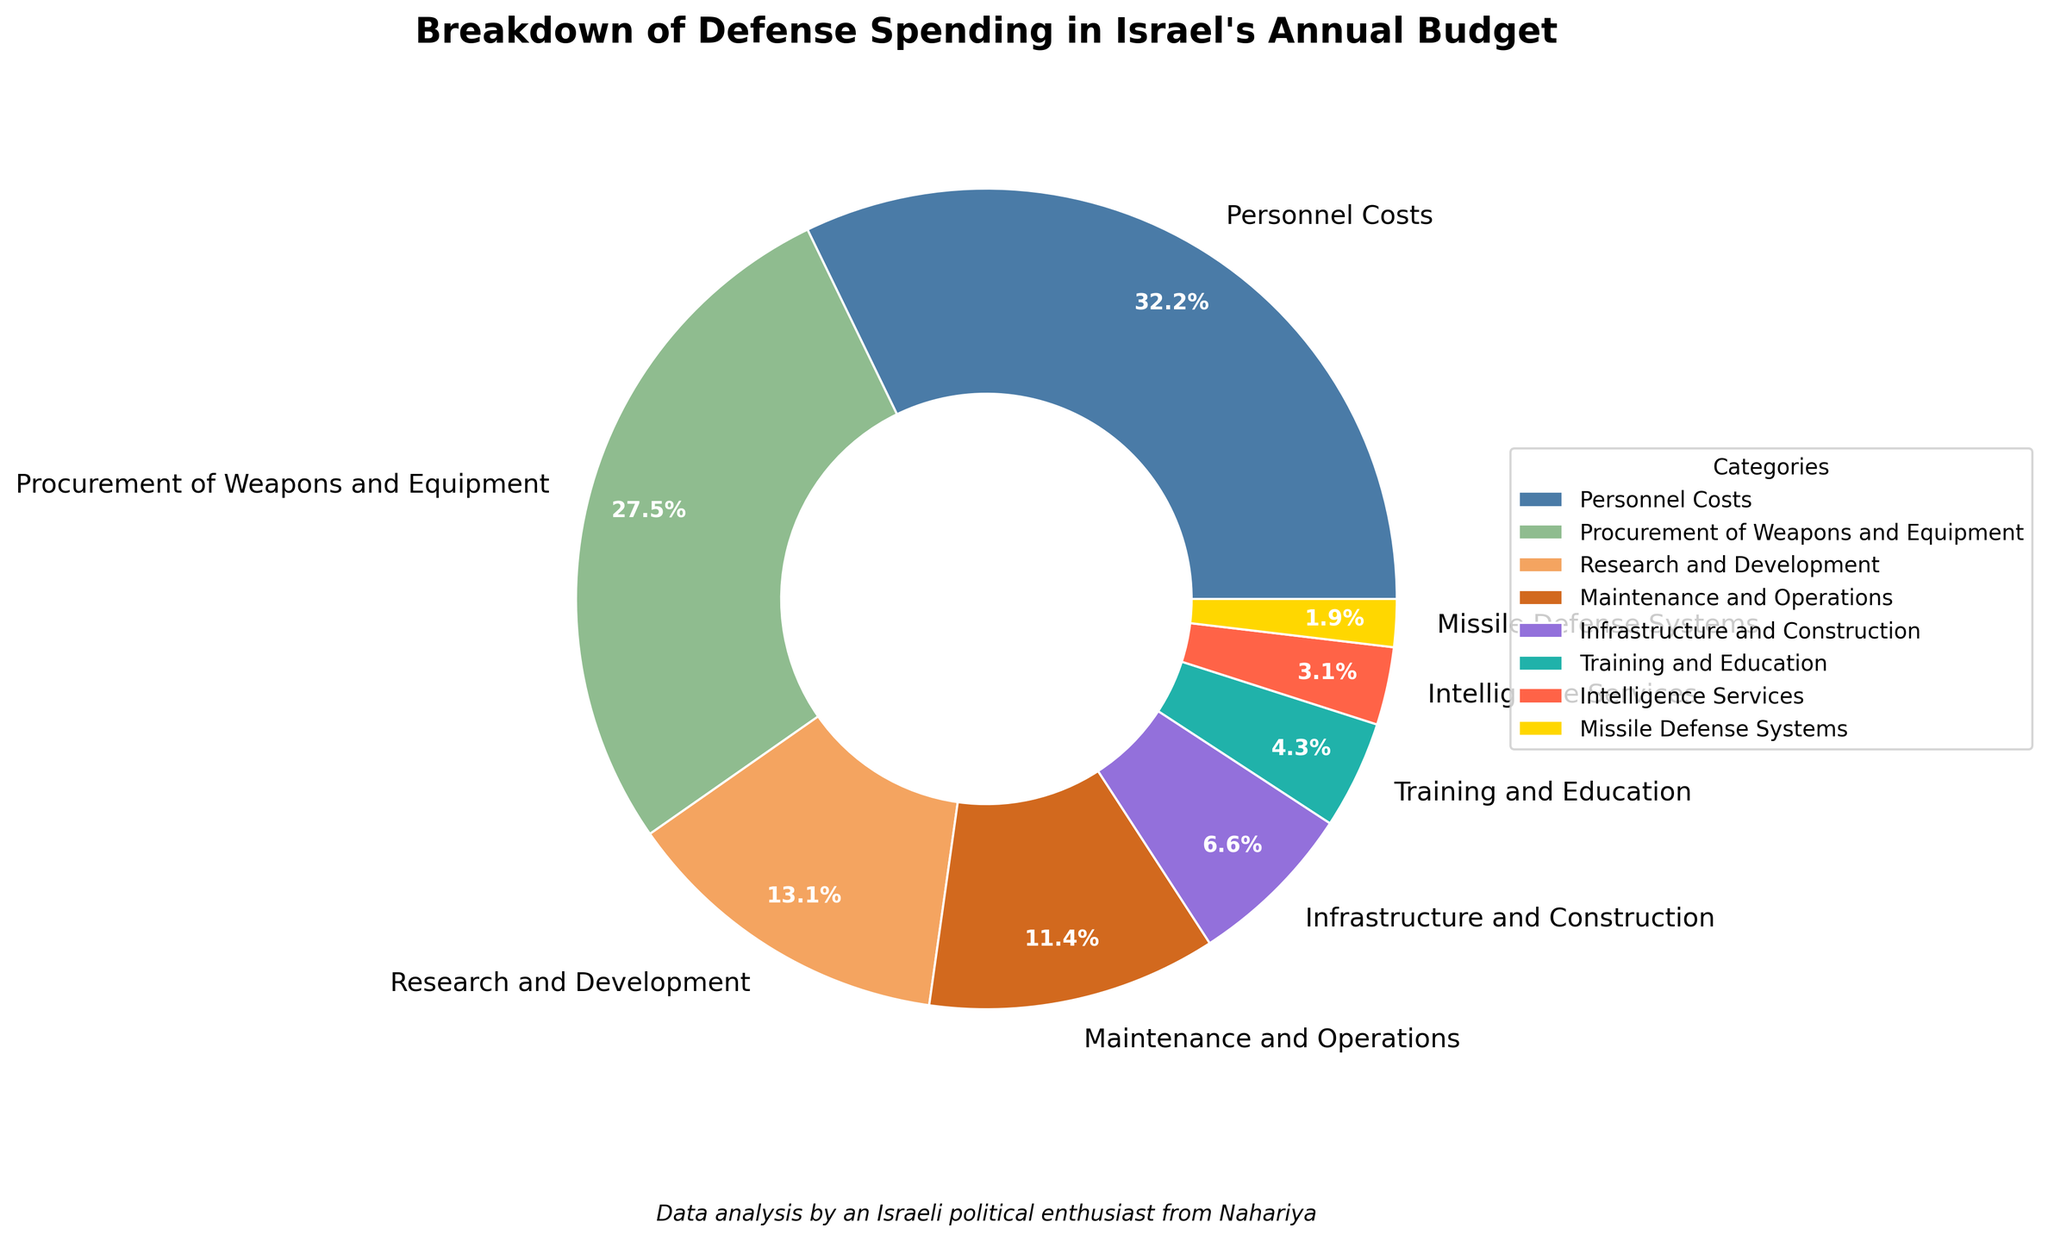What's the largest spending category for Israel's defense budget? The largest wedge and the label with the highest percentage indicate the largest spending category. Here, "Personnel Costs" has a percentage of 32.5%.
Answer: Personnel Costs Which category has the smallest percentage of Israel's defense spending? The wedge labeled with the smallest percentage is the smallest spending category. Here, "Missile Defense Systems" has 1.9%.
Answer: Missile Defense Systems How much more is spent on procurement of weapons and equipment compared to missile defense systems? Subtract the percentage of spending on missile defense systems from the percentage of spending on procurement of weapons and equipment: 27.8% - 1.9% = 25.9%.
Answer: 25.9% What is the combined percentage of spending on research and development and intelligence services? Add the percentages of spending on these two categories: 13.2% + 3.1% = 16.3%.
Answer: 16.3% Which category has a higher percentage of spending: maintenance and operations or infrastructure and construction? Compare the percentages: Maintenance and Operations (11.5%) is higher than Infrastructure and Construction (6.7%).
Answer: Maintenance and Operations What percentage of the budget is spent on categories with less than 10% each? Sum the percentages of all categories with less than 10%: 6.7% (Infrastructure and Construction) + 4.3% (Training and Education) + 3.1% (Intelligence Services) + 1.9% (Missile Defense Systems) = 16.0%.
Answer: 16.0% Compare the total spending on personnel costs and procurement of weapons and equipment. Add the percentages for a combined total: 32.5% (Personnel Costs) + 27.8% (Procurement of Weapons and Equipment) = 60.3%.
Answer: 60.3% How does the spending on training and education compare with procurement of weapons and equipment? The percentage for Training and Education (4.3%) is much smaller than for Procurement of Weapons and Equipment (27.8%).
Answer: Procurement of Weapons and Equipment is higher What portion of the budget does missile defense systems account for compared to the total? Simply refer to the percentage of the budget allocated to missile defense systems, which is 1.9%.
Answer: 1.9% How does the spending on infrastructure and construction compare with maintenance and operations? Compare the percentages: the spending on Maintenance and Operations (11.5%) is higher than on Infrastructure and Construction (6.7%).
Answer: Maintenance and Operations is higher 